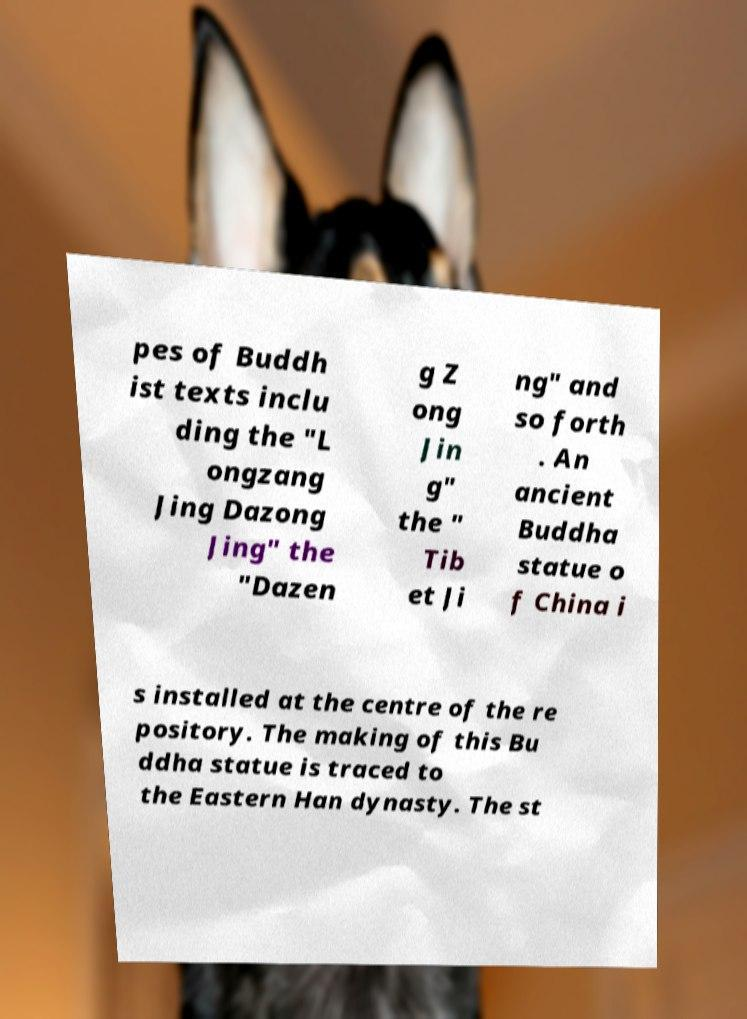Can you accurately transcribe the text from the provided image for me? pes of Buddh ist texts inclu ding the "L ongzang Jing Dazong Jing" the "Dazen g Z ong Jin g" the " Tib et Ji ng" and so forth . An ancient Buddha statue o f China i s installed at the centre of the re pository. The making of this Bu ddha statue is traced to the Eastern Han dynasty. The st 